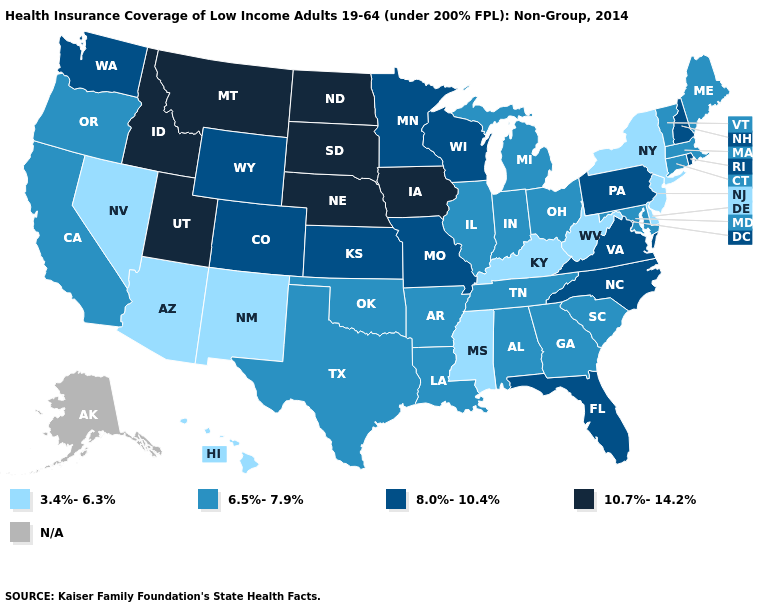How many symbols are there in the legend?
Short answer required. 5. What is the highest value in the USA?
Concise answer only. 10.7%-14.2%. Which states have the lowest value in the South?
Quick response, please. Delaware, Kentucky, Mississippi, West Virginia. What is the lowest value in the USA?
Short answer required. 3.4%-6.3%. Name the states that have a value in the range N/A?
Short answer required. Alaska. What is the value of Minnesota?
Short answer required. 8.0%-10.4%. Name the states that have a value in the range 10.7%-14.2%?
Quick response, please. Idaho, Iowa, Montana, Nebraska, North Dakota, South Dakota, Utah. Does New York have the lowest value in the USA?
Be succinct. Yes. Which states hav the highest value in the South?
Answer briefly. Florida, North Carolina, Virginia. Name the states that have a value in the range 3.4%-6.3%?
Answer briefly. Arizona, Delaware, Hawaii, Kentucky, Mississippi, Nevada, New Jersey, New Mexico, New York, West Virginia. What is the value of Kansas?
Be succinct. 8.0%-10.4%. What is the value of New York?
Answer briefly. 3.4%-6.3%. 